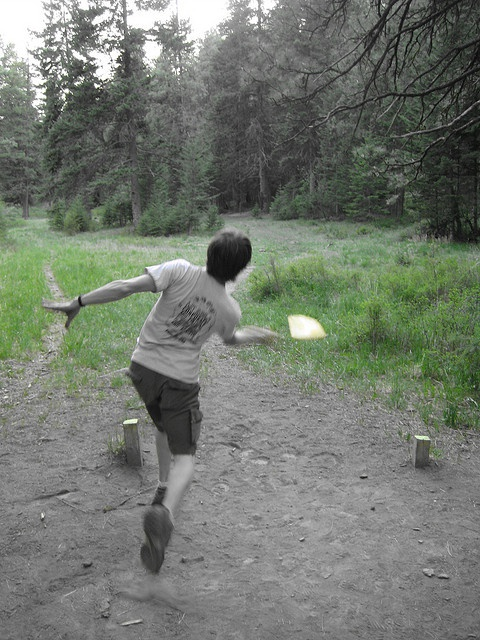Describe the objects in this image and their specific colors. I can see people in white, gray, darkgray, black, and lightgray tones and frisbee in white, ivory, beige, and olive tones in this image. 